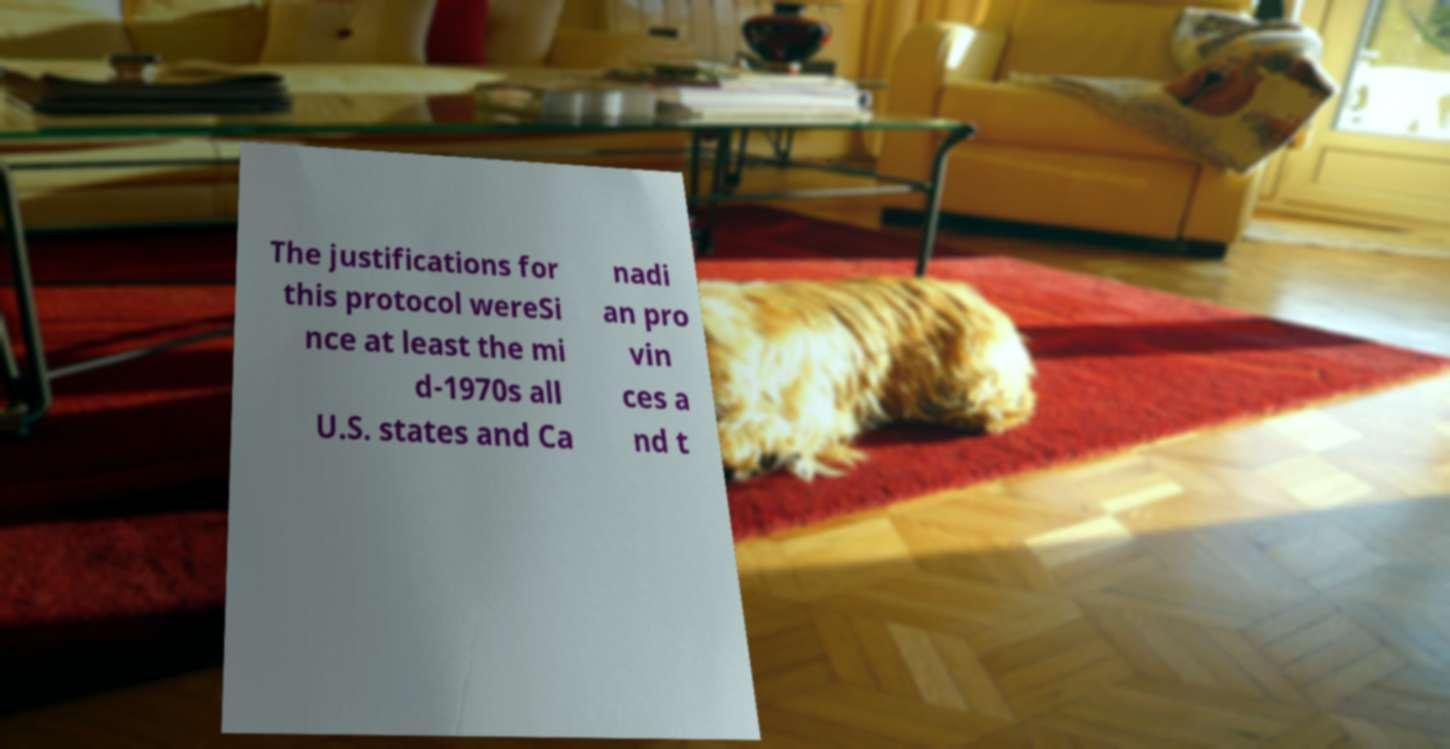There's text embedded in this image that I need extracted. Can you transcribe it verbatim? The justifications for this protocol wereSi nce at least the mi d-1970s all U.S. states and Ca nadi an pro vin ces a nd t 